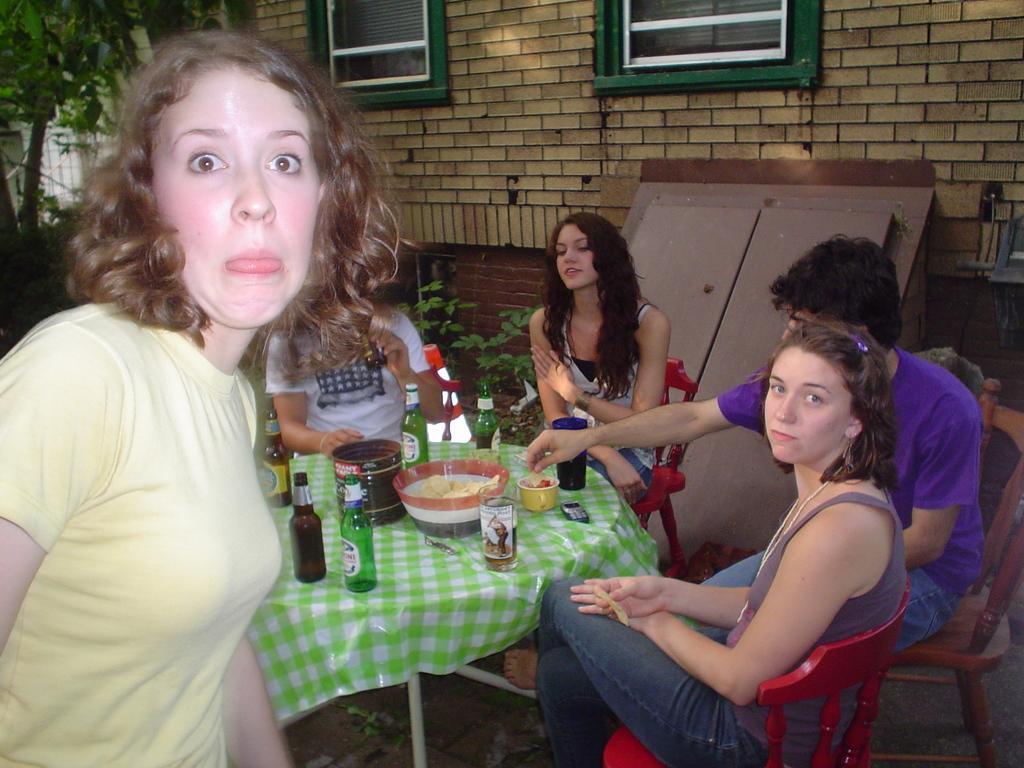Can you describe this image briefly? In this picture we can see woman standing with some expression and at back people are sitting on chair and in front of them there is table and on table we can see bowl, bottles, cup, bucket and in background we can see house with windows, tree, some metal, net. 